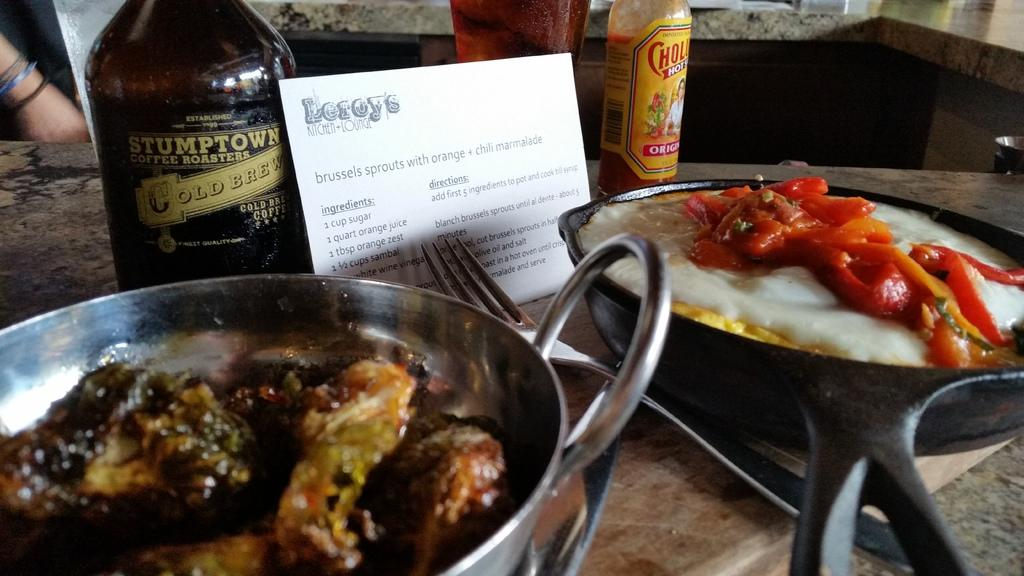What type of furniture is visible in the image? There is a table in the image. What can be found on the table? There are eatable things and spoons on the table. Are there any beverage containers on the table? Yes, there are bottles on the table. What type of ornament is hanging from the ceiling in the image? There is no ornament hanging from the ceiling in the image. 